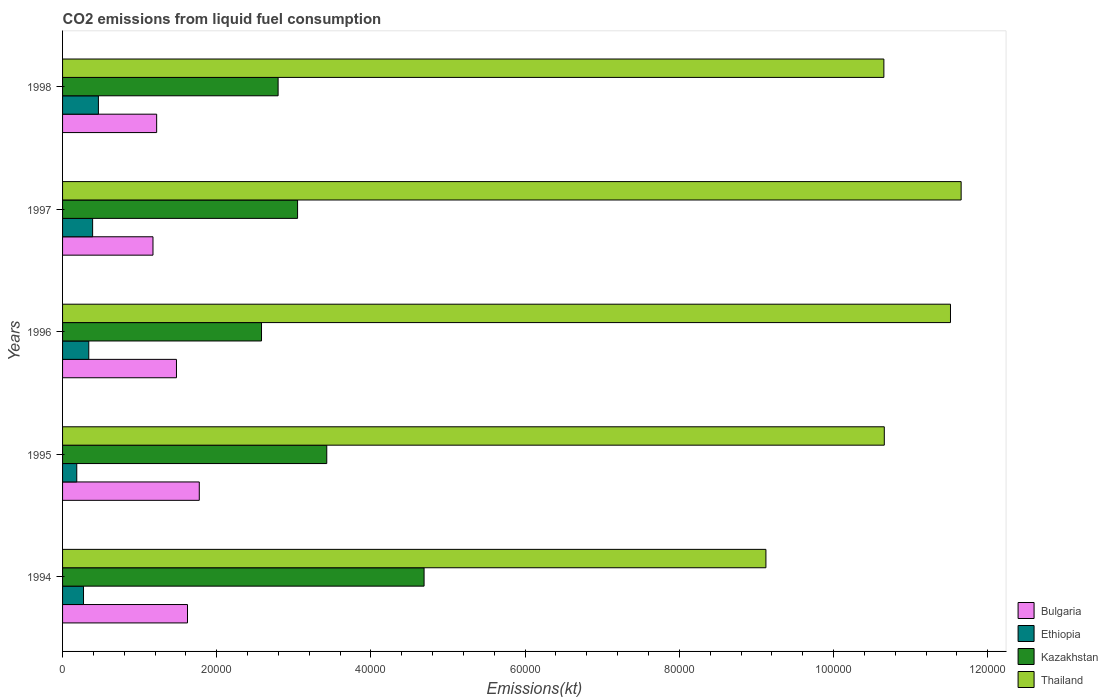How many different coloured bars are there?
Offer a very short reply. 4. How many groups of bars are there?
Your answer should be compact. 5. Are the number of bars on each tick of the Y-axis equal?
Keep it short and to the point. Yes. How many bars are there on the 5th tick from the top?
Provide a short and direct response. 4. What is the label of the 3rd group of bars from the top?
Keep it short and to the point. 1996. What is the amount of CO2 emitted in Kazakhstan in 1995?
Your response must be concise. 3.43e+04. Across all years, what is the maximum amount of CO2 emitted in Bulgaria?
Your response must be concise. 1.77e+04. Across all years, what is the minimum amount of CO2 emitted in Kazakhstan?
Offer a terse response. 2.58e+04. In which year was the amount of CO2 emitted in Thailand maximum?
Provide a succinct answer. 1997. In which year was the amount of CO2 emitted in Bulgaria minimum?
Provide a short and direct response. 1997. What is the total amount of CO2 emitted in Thailand in the graph?
Keep it short and to the point. 5.36e+05. What is the difference between the amount of CO2 emitted in Kazakhstan in 1997 and that in 1998?
Your answer should be compact. 2526.56. What is the difference between the amount of CO2 emitted in Bulgaria in 1996 and the amount of CO2 emitted in Ethiopia in 1995?
Offer a very short reply. 1.29e+04. What is the average amount of CO2 emitted in Thailand per year?
Your response must be concise. 1.07e+05. In the year 1994, what is the difference between the amount of CO2 emitted in Thailand and amount of CO2 emitted in Bulgaria?
Provide a short and direct response. 7.50e+04. In how many years, is the amount of CO2 emitted in Ethiopia greater than 112000 kt?
Your answer should be compact. 0. What is the ratio of the amount of CO2 emitted in Ethiopia in 1994 to that in 1998?
Provide a succinct answer. 0.58. Is the difference between the amount of CO2 emitted in Thailand in 1995 and 1996 greater than the difference between the amount of CO2 emitted in Bulgaria in 1995 and 1996?
Make the answer very short. No. What is the difference between the highest and the second highest amount of CO2 emitted in Bulgaria?
Your answer should be compact. 1529.14. What is the difference between the highest and the lowest amount of CO2 emitted in Kazakhstan?
Give a very brief answer. 2.11e+04. In how many years, is the amount of CO2 emitted in Bulgaria greater than the average amount of CO2 emitted in Bulgaria taken over all years?
Offer a terse response. 3. What does the 2nd bar from the top in 1997 represents?
Offer a very short reply. Kazakhstan. What does the 3rd bar from the bottom in 1997 represents?
Your answer should be compact. Kazakhstan. Are all the bars in the graph horizontal?
Make the answer very short. Yes. How many years are there in the graph?
Offer a very short reply. 5. Are the values on the major ticks of X-axis written in scientific E-notation?
Provide a short and direct response. No. Does the graph contain grids?
Keep it short and to the point. No. What is the title of the graph?
Provide a succinct answer. CO2 emissions from liquid fuel consumption. What is the label or title of the X-axis?
Keep it short and to the point. Emissions(kt). What is the label or title of the Y-axis?
Provide a succinct answer. Years. What is the Emissions(kt) of Bulgaria in 1994?
Your answer should be very brief. 1.62e+04. What is the Emissions(kt) of Ethiopia in 1994?
Offer a very short reply. 2717.25. What is the Emissions(kt) in Kazakhstan in 1994?
Provide a short and direct response. 4.69e+04. What is the Emissions(kt) in Thailand in 1994?
Provide a succinct answer. 9.12e+04. What is the Emissions(kt) of Bulgaria in 1995?
Offer a very short reply. 1.77e+04. What is the Emissions(kt) of Ethiopia in 1995?
Your response must be concise. 1840.83. What is the Emissions(kt) in Kazakhstan in 1995?
Keep it short and to the point. 3.43e+04. What is the Emissions(kt) in Thailand in 1995?
Provide a succinct answer. 1.07e+05. What is the Emissions(kt) in Bulgaria in 1996?
Your answer should be compact. 1.48e+04. What is the Emissions(kt) of Ethiopia in 1996?
Give a very brief answer. 3399.31. What is the Emissions(kt) in Kazakhstan in 1996?
Give a very brief answer. 2.58e+04. What is the Emissions(kt) of Thailand in 1996?
Offer a very short reply. 1.15e+05. What is the Emissions(kt) of Bulgaria in 1997?
Ensure brevity in your answer.  1.17e+04. What is the Emissions(kt) in Ethiopia in 1997?
Your response must be concise. 3898.02. What is the Emissions(kt) in Kazakhstan in 1997?
Ensure brevity in your answer.  3.05e+04. What is the Emissions(kt) of Thailand in 1997?
Your answer should be compact. 1.17e+05. What is the Emissions(kt) in Bulgaria in 1998?
Provide a succinct answer. 1.22e+04. What is the Emissions(kt) of Ethiopia in 1998?
Make the answer very short. 4649.76. What is the Emissions(kt) of Kazakhstan in 1998?
Your answer should be compact. 2.80e+04. What is the Emissions(kt) of Thailand in 1998?
Give a very brief answer. 1.07e+05. Across all years, what is the maximum Emissions(kt) in Bulgaria?
Provide a short and direct response. 1.77e+04. Across all years, what is the maximum Emissions(kt) of Ethiopia?
Give a very brief answer. 4649.76. Across all years, what is the maximum Emissions(kt) of Kazakhstan?
Provide a succinct answer. 4.69e+04. Across all years, what is the maximum Emissions(kt) of Thailand?
Your response must be concise. 1.17e+05. Across all years, what is the minimum Emissions(kt) in Bulgaria?
Your answer should be compact. 1.17e+04. Across all years, what is the minimum Emissions(kt) in Ethiopia?
Offer a very short reply. 1840.83. Across all years, what is the minimum Emissions(kt) of Kazakhstan?
Ensure brevity in your answer.  2.58e+04. Across all years, what is the minimum Emissions(kt) in Thailand?
Your answer should be compact. 9.12e+04. What is the total Emissions(kt) in Bulgaria in the graph?
Your answer should be very brief. 7.26e+04. What is the total Emissions(kt) of Ethiopia in the graph?
Make the answer very short. 1.65e+04. What is the total Emissions(kt) in Kazakhstan in the graph?
Your answer should be compact. 1.65e+05. What is the total Emissions(kt) of Thailand in the graph?
Provide a short and direct response. 5.36e+05. What is the difference between the Emissions(kt) in Bulgaria in 1994 and that in 1995?
Provide a succinct answer. -1529.14. What is the difference between the Emissions(kt) of Ethiopia in 1994 and that in 1995?
Provide a short and direct response. 876.41. What is the difference between the Emissions(kt) in Kazakhstan in 1994 and that in 1995?
Your response must be concise. 1.26e+04. What is the difference between the Emissions(kt) of Thailand in 1994 and that in 1995?
Offer a very short reply. -1.54e+04. What is the difference between the Emissions(kt) in Bulgaria in 1994 and that in 1996?
Ensure brevity in your answer.  1430.13. What is the difference between the Emissions(kt) of Ethiopia in 1994 and that in 1996?
Give a very brief answer. -682.06. What is the difference between the Emissions(kt) in Kazakhstan in 1994 and that in 1996?
Your answer should be very brief. 2.11e+04. What is the difference between the Emissions(kt) in Thailand in 1994 and that in 1996?
Make the answer very short. -2.39e+04. What is the difference between the Emissions(kt) of Bulgaria in 1994 and that in 1997?
Offer a terse response. 4477.41. What is the difference between the Emissions(kt) in Ethiopia in 1994 and that in 1997?
Provide a short and direct response. -1180.77. What is the difference between the Emissions(kt) of Kazakhstan in 1994 and that in 1997?
Provide a succinct answer. 1.64e+04. What is the difference between the Emissions(kt) in Thailand in 1994 and that in 1997?
Provide a succinct answer. -2.53e+04. What is the difference between the Emissions(kt) in Bulgaria in 1994 and that in 1998?
Provide a succinct answer. 4000.7. What is the difference between the Emissions(kt) in Ethiopia in 1994 and that in 1998?
Provide a succinct answer. -1932.51. What is the difference between the Emissions(kt) of Kazakhstan in 1994 and that in 1998?
Offer a terse response. 1.89e+04. What is the difference between the Emissions(kt) of Thailand in 1994 and that in 1998?
Provide a succinct answer. -1.53e+04. What is the difference between the Emissions(kt) of Bulgaria in 1995 and that in 1996?
Your response must be concise. 2959.27. What is the difference between the Emissions(kt) in Ethiopia in 1995 and that in 1996?
Give a very brief answer. -1558.47. What is the difference between the Emissions(kt) in Kazakhstan in 1995 and that in 1996?
Offer a very short reply. 8463.44. What is the difference between the Emissions(kt) of Thailand in 1995 and that in 1996?
Your response must be concise. -8584.45. What is the difference between the Emissions(kt) in Bulgaria in 1995 and that in 1997?
Your answer should be very brief. 6006.55. What is the difference between the Emissions(kt) in Ethiopia in 1995 and that in 1997?
Your response must be concise. -2057.19. What is the difference between the Emissions(kt) in Kazakhstan in 1995 and that in 1997?
Your answer should be compact. 3784.34. What is the difference between the Emissions(kt) in Thailand in 1995 and that in 1997?
Ensure brevity in your answer.  -9966.91. What is the difference between the Emissions(kt) in Bulgaria in 1995 and that in 1998?
Your response must be concise. 5529.84. What is the difference between the Emissions(kt) in Ethiopia in 1995 and that in 1998?
Provide a succinct answer. -2808.92. What is the difference between the Emissions(kt) in Kazakhstan in 1995 and that in 1998?
Make the answer very short. 6310.91. What is the difference between the Emissions(kt) of Thailand in 1995 and that in 1998?
Give a very brief answer. 55.01. What is the difference between the Emissions(kt) in Bulgaria in 1996 and that in 1997?
Give a very brief answer. 3047.28. What is the difference between the Emissions(kt) of Ethiopia in 1996 and that in 1997?
Your answer should be very brief. -498.71. What is the difference between the Emissions(kt) in Kazakhstan in 1996 and that in 1997?
Make the answer very short. -4679.09. What is the difference between the Emissions(kt) of Thailand in 1996 and that in 1997?
Your answer should be compact. -1382.46. What is the difference between the Emissions(kt) in Bulgaria in 1996 and that in 1998?
Your response must be concise. 2570.57. What is the difference between the Emissions(kt) in Ethiopia in 1996 and that in 1998?
Your response must be concise. -1250.45. What is the difference between the Emissions(kt) of Kazakhstan in 1996 and that in 1998?
Your answer should be compact. -2152.53. What is the difference between the Emissions(kt) in Thailand in 1996 and that in 1998?
Offer a terse response. 8639.45. What is the difference between the Emissions(kt) of Bulgaria in 1997 and that in 1998?
Provide a short and direct response. -476.71. What is the difference between the Emissions(kt) of Ethiopia in 1997 and that in 1998?
Offer a terse response. -751.74. What is the difference between the Emissions(kt) in Kazakhstan in 1997 and that in 1998?
Make the answer very short. 2526.56. What is the difference between the Emissions(kt) in Thailand in 1997 and that in 1998?
Provide a succinct answer. 1.00e+04. What is the difference between the Emissions(kt) in Bulgaria in 1994 and the Emissions(kt) in Ethiopia in 1995?
Provide a short and direct response. 1.44e+04. What is the difference between the Emissions(kt) of Bulgaria in 1994 and the Emissions(kt) of Kazakhstan in 1995?
Provide a succinct answer. -1.81e+04. What is the difference between the Emissions(kt) of Bulgaria in 1994 and the Emissions(kt) of Thailand in 1995?
Keep it short and to the point. -9.04e+04. What is the difference between the Emissions(kt) of Ethiopia in 1994 and the Emissions(kt) of Kazakhstan in 1995?
Your answer should be very brief. -3.16e+04. What is the difference between the Emissions(kt) in Ethiopia in 1994 and the Emissions(kt) in Thailand in 1995?
Ensure brevity in your answer.  -1.04e+05. What is the difference between the Emissions(kt) in Kazakhstan in 1994 and the Emissions(kt) in Thailand in 1995?
Keep it short and to the point. -5.97e+04. What is the difference between the Emissions(kt) of Bulgaria in 1994 and the Emissions(kt) of Ethiopia in 1996?
Keep it short and to the point. 1.28e+04. What is the difference between the Emissions(kt) of Bulgaria in 1994 and the Emissions(kt) of Kazakhstan in 1996?
Your answer should be very brief. -9600.21. What is the difference between the Emissions(kt) of Bulgaria in 1994 and the Emissions(kt) of Thailand in 1996?
Keep it short and to the point. -9.90e+04. What is the difference between the Emissions(kt) in Ethiopia in 1994 and the Emissions(kt) in Kazakhstan in 1996?
Your answer should be very brief. -2.31e+04. What is the difference between the Emissions(kt) of Ethiopia in 1994 and the Emissions(kt) of Thailand in 1996?
Offer a very short reply. -1.12e+05. What is the difference between the Emissions(kt) in Kazakhstan in 1994 and the Emissions(kt) in Thailand in 1996?
Offer a very short reply. -6.83e+04. What is the difference between the Emissions(kt) in Bulgaria in 1994 and the Emissions(kt) in Ethiopia in 1997?
Give a very brief answer. 1.23e+04. What is the difference between the Emissions(kt) of Bulgaria in 1994 and the Emissions(kt) of Kazakhstan in 1997?
Keep it short and to the point. -1.43e+04. What is the difference between the Emissions(kt) of Bulgaria in 1994 and the Emissions(kt) of Thailand in 1997?
Your response must be concise. -1.00e+05. What is the difference between the Emissions(kt) in Ethiopia in 1994 and the Emissions(kt) in Kazakhstan in 1997?
Provide a succinct answer. -2.78e+04. What is the difference between the Emissions(kt) of Ethiopia in 1994 and the Emissions(kt) of Thailand in 1997?
Offer a terse response. -1.14e+05. What is the difference between the Emissions(kt) of Kazakhstan in 1994 and the Emissions(kt) of Thailand in 1997?
Keep it short and to the point. -6.97e+04. What is the difference between the Emissions(kt) of Bulgaria in 1994 and the Emissions(kt) of Ethiopia in 1998?
Keep it short and to the point. 1.16e+04. What is the difference between the Emissions(kt) in Bulgaria in 1994 and the Emissions(kt) in Kazakhstan in 1998?
Offer a very short reply. -1.18e+04. What is the difference between the Emissions(kt) of Bulgaria in 1994 and the Emissions(kt) of Thailand in 1998?
Keep it short and to the point. -9.03e+04. What is the difference between the Emissions(kt) of Ethiopia in 1994 and the Emissions(kt) of Kazakhstan in 1998?
Give a very brief answer. -2.52e+04. What is the difference between the Emissions(kt) of Ethiopia in 1994 and the Emissions(kt) of Thailand in 1998?
Provide a short and direct response. -1.04e+05. What is the difference between the Emissions(kt) in Kazakhstan in 1994 and the Emissions(kt) in Thailand in 1998?
Your response must be concise. -5.96e+04. What is the difference between the Emissions(kt) in Bulgaria in 1995 and the Emissions(kt) in Ethiopia in 1996?
Your response must be concise. 1.43e+04. What is the difference between the Emissions(kt) in Bulgaria in 1995 and the Emissions(kt) in Kazakhstan in 1996?
Offer a very short reply. -8071.07. What is the difference between the Emissions(kt) in Bulgaria in 1995 and the Emissions(kt) in Thailand in 1996?
Make the answer very short. -9.74e+04. What is the difference between the Emissions(kt) of Ethiopia in 1995 and the Emissions(kt) of Kazakhstan in 1996?
Provide a short and direct response. -2.40e+04. What is the difference between the Emissions(kt) in Ethiopia in 1995 and the Emissions(kt) in Thailand in 1996?
Provide a short and direct response. -1.13e+05. What is the difference between the Emissions(kt) of Kazakhstan in 1995 and the Emissions(kt) of Thailand in 1996?
Provide a succinct answer. -8.09e+04. What is the difference between the Emissions(kt) in Bulgaria in 1995 and the Emissions(kt) in Ethiopia in 1997?
Your answer should be compact. 1.38e+04. What is the difference between the Emissions(kt) of Bulgaria in 1995 and the Emissions(kt) of Kazakhstan in 1997?
Your answer should be compact. -1.28e+04. What is the difference between the Emissions(kt) of Bulgaria in 1995 and the Emissions(kt) of Thailand in 1997?
Your answer should be very brief. -9.88e+04. What is the difference between the Emissions(kt) of Ethiopia in 1995 and the Emissions(kt) of Kazakhstan in 1997?
Offer a very short reply. -2.86e+04. What is the difference between the Emissions(kt) in Ethiopia in 1995 and the Emissions(kt) in Thailand in 1997?
Your response must be concise. -1.15e+05. What is the difference between the Emissions(kt) of Kazakhstan in 1995 and the Emissions(kt) of Thailand in 1997?
Your answer should be very brief. -8.23e+04. What is the difference between the Emissions(kt) of Bulgaria in 1995 and the Emissions(kt) of Ethiopia in 1998?
Ensure brevity in your answer.  1.31e+04. What is the difference between the Emissions(kt) of Bulgaria in 1995 and the Emissions(kt) of Kazakhstan in 1998?
Give a very brief answer. -1.02e+04. What is the difference between the Emissions(kt) of Bulgaria in 1995 and the Emissions(kt) of Thailand in 1998?
Provide a succinct answer. -8.88e+04. What is the difference between the Emissions(kt) of Ethiopia in 1995 and the Emissions(kt) of Kazakhstan in 1998?
Provide a short and direct response. -2.61e+04. What is the difference between the Emissions(kt) of Ethiopia in 1995 and the Emissions(kt) of Thailand in 1998?
Provide a short and direct response. -1.05e+05. What is the difference between the Emissions(kt) of Kazakhstan in 1995 and the Emissions(kt) of Thailand in 1998?
Your response must be concise. -7.23e+04. What is the difference between the Emissions(kt) in Bulgaria in 1996 and the Emissions(kt) in Ethiopia in 1997?
Make the answer very short. 1.09e+04. What is the difference between the Emissions(kt) of Bulgaria in 1996 and the Emissions(kt) of Kazakhstan in 1997?
Ensure brevity in your answer.  -1.57e+04. What is the difference between the Emissions(kt) of Bulgaria in 1996 and the Emissions(kt) of Thailand in 1997?
Provide a succinct answer. -1.02e+05. What is the difference between the Emissions(kt) of Ethiopia in 1996 and the Emissions(kt) of Kazakhstan in 1997?
Offer a very short reply. -2.71e+04. What is the difference between the Emissions(kt) of Ethiopia in 1996 and the Emissions(kt) of Thailand in 1997?
Your response must be concise. -1.13e+05. What is the difference between the Emissions(kt) of Kazakhstan in 1996 and the Emissions(kt) of Thailand in 1997?
Provide a short and direct response. -9.07e+04. What is the difference between the Emissions(kt) in Bulgaria in 1996 and the Emissions(kt) in Ethiopia in 1998?
Offer a terse response. 1.01e+04. What is the difference between the Emissions(kt) of Bulgaria in 1996 and the Emissions(kt) of Kazakhstan in 1998?
Offer a very short reply. -1.32e+04. What is the difference between the Emissions(kt) of Bulgaria in 1996 and the Emissions(kt) of Thailand in 1998?
Make the answer very short. -9.18e+04. What is the difference between the Emissions(kt) of Ethiopia in 1996 and the Emissions(kt) of Kazakhstan in 1998?
Provide a short and direct response. -2.46e+04. What is the difference between the Emissions(kt) of Ethiopia in 1996 and the Emissions(kt) of Thailand in 1998?
Offer a terse response. -1.03e+05. What is the difference between the Emissions(kt) in Kazakhstan in 1996 and the Emissions(kt) in Thailand in 1998?
Offer a very short reply. -8.07e+04. What is the difference between the Emissions(kt) of Bulgaria in 1997 and the Emissions(kt) of Ethiopia in 1998?
Offer a very short reply. 7077.31. What is the difference between the Emissions(kt) in Bulgaria in 1997 and the Emissions(kt) in Kazakhstan in 1998?
Keep it short and to the point. -1.62e+04. What is the difference between the Emissions(kt) in Bulgaria in 1997 and the Emissions(kt) in Thailand in 1998?
Make the answer very short. -9.48e+04. What is the difference between the Emissions(kt) of Ethiopia in 1997 and the Emissions(kt) of Kazakhstan in 1998?
Keep it short and to the point. -2.41e+04. What is the difference between the Emissions(kt) of Ethiopia in 1997 and the Emissions(kt) of Thailand in 1998?
Offer a very short reply. -1.03e+05. What is the difference between the Emissions(kt) in Kazakhstan in 1997 and the Emissions(kt) in Thailand in 1998?
Your answer should be compact. -7.60e+04. What is the average Emissions(kt) of Bulgaria per year?
Make the answer very short. 1.45e+04. What is the average Emissions(kt) in Ethiopia per year?
Give a very brief answer. 3301.03. What is the average Emissions(kt) of Kazakhstan per year?
Offer a terse response. 3.31e+04. What is the average Emissions(kt) of Thailand per year?
Offer a terse response. 1.07e+05. In the year 1994, what is the difference between the Emissions(kt) of Bulgaria and Emissions(kt) of Ethiopia?
Provide a succinct answer. 1.35e+04. In the year 1994, what is the difference between the Emissions(kt) in Bulgaria and Emissions(kt) in Kazakhstan?
Offer a terse response. -3.07e+04. In the year 1994, what is the difference between the Emissions(kt) in Bulgaria and Emissions(kt) in Thailand?
Give a very brief answer. -7.50e+04. In the year 1994, what is the difference between the Emissions(kt) of Ethiopia and Emissions(kt) of Kazakhstan?
Offer a very short reply. -4.42e+04. In the year 1994, what is the difference between the Emissions(kt) in Ethiopia and Emissions(kt) in Thailand?
Offer a terse response. -8.85e+04. In the year 1994, what is the difference between the Emissions(kt) of Kazakhstan and Emissions(kt) of Thailand?
Give a very brief answer. -4.43e+04. In the year 1995, what is the difference between the Emissions(kt) of Bulgaria and Emissions(kt) of Ethiopia?
Ensure brevity in your answer.  1.59e+04. In the year 1995, what is the difference between the Emissions(kt) in Bulgaria and Emissions(kt) in Kazakhstan?
Your answer should be very brief. -1.65e+04. In the year 1995, what is the difference between the Emissions(kt) in Bulgaria and Emissions(kt) in Thailand?
Offer a very short reply. -8.89e+04. In the year 1995, what is the difference between the Emissions(kt) in Ethiopia and Emissions(kt) in Kazakhstan?
Make the answer very short. -3.24e+04. In the year 1995, what is the difference between the Emissions(kt) in Ethiopia and Emissions(kt) in Thailand?
Your answer should be compact. -1.05e+05. In the year 1995, what is the difference between the Emissions(kt) of Kazakhstan and Emissions(kt) of Thailand?
Your answer should be compact. -7.23e+04. In the year 1996, what is the difference between the Emissions(kt) of Bulgaria and Emissions(kt) of Ethiopia?
Keep it short and to the point. 1.14e+04. In the year 1996, what is the difference between the Emissions(kt) in Bulgaria and Emissions(kt) in Kazakhstan?
Your answer should be very brief. -1.10e+04. In the year 1996, what is the difference between the Emissions(kt) of Bulgaria and Emissions(kt) of Thailand?
Keep it short and to the point. -1.00e+05. In the year 1996, what is the difference between the Emissions(kt) of Ethiopia and Emissions(kt) of Kazakhstan?
Provide a short and direct response. -2.24e+04. In the year 1996, what is the difference between the Emissions(kt) of Ethiopia and Emissions(kt) of Thailand?
Ensure brevity in your answer.  -1.12e+05. In the year 1996, what is the difference between the Emissions(kt) of Kazakhstan and Emissions(kt) of Thailand?
Offer a very short reply. -8.94e+04. In the year 1997, what is the difference between the Emissions(kt) in Bulgaria and Emissions(kt) in Ethiopia?
Keep it short and to the point. 7829.05. In the year 1997, what is the difference between the Emissions(kt) in Bulgaria and Emissions(kt) in Kazakhstan?
Your answer should be very brief. -1.88e+04. In the year 1997, what is the difference between the Emissions(kt) of Bulgaria and Emissions(kt) of Thailand?
Ensure brevity in your answer.  -1.05e+05. In the year 1997, what is the difference between the Emissions(kt) of Ethiopia and Emissions(kt) of Kazakhstan?
Keep it short and to the point. -2.66e+04. In the year 1997, what is the difference between the Emissions(kt) in Ethiopia and Emissions(kt) in Thailand?
Make the answer very short. -1.13e+05. In the year 1997, what is the difference between the Emissions(kt) of Kazakhstan and Emissions(kt) of Thailand?
Your answer should be compact. -8.61e+04. In the year 1998, what is the difference between the Emissions(kt) of Bulgaria and Emissions(kt) of Ethiopia?
Keep it short and to the point. 7554.02. In the year 1998, what is the difference between the Emissions(kt) in Bulgaria and Emissions(kt) in Kazakhstan?
Offer a very short reply. -1.58e+04. In the year 1998, what is the difference between the Emissions(kt) of Bulgaria and Emissions(kt) of Thailand?
Provide a succinct answer. -9.43e+04. In the year 1998, what is the difference between the Emissions(kt) in Ethiopia and Emissions(kt) in Kazakhstan?
Offer a terse response. -2.33e+04. In the year 1998, what is the difference between the Emissions(kt) in Ethiopia and Emissions(kt) in Thailand?
Offer a terse response. -1.02e+05. In the year 1998, what is the difference between the Emissions(kt) in Kazakhstan and Emissions(kt) in Thailand?
Provide a succinct answer. -7.86e+04. What is the ratio of the Emissions(kt) of Bulgaria in 1994 to that in 1995?
Offer a terse response. 0.91. What is the ratio of the Emissions(kt) of Ethiopia in 1994 to that in 1995?
Provide a succinct answer. 1.48. What is the ratio of the Emissions(kt) of Kazakhstan in 1994 to that in 1995?
Provide a short and direct response. 1.37. What is the ratio of the Emissions(kt) in Thailand in 1994 to that in 1995?
Ensure brevity in your answer.  0.86. What is the ratio of the Emissions(kt) in Bulgaria in 1994 to that in 1996?
Keep it short and to the point. 1.1. What is the ratio of the Emissions(kt) of Ethiopia in 1994 to that in 1996?
Ensure brevity in your answer.  0.8. What is the ratio of the Emissions(kt) in Kazakhstan in 1994 to that in 1996?
Provide a succinct answer. 1.82. What is the ratio of the Emissions(kt) in Thailand in 1994 to that in 1996?
Give a very brief answer. 0.79. What is the ratio of the Emissions(kt) of Bulgaria in 1994 to that in 1997?
Your response must be concise. 1.38. What is the ratio of the Emissions(kt) of Ethiopia in 1994 to that in 1997?
Keep it short and to the point. 0.7. What is the ratio of the Emissions(kt) of Kazakhstan in 1994 to that in 1997?
Your response must be concise. 1.54. What is the ratio of the Emissions(kt) of Thailand in 1994 to that in 1997?
Keep it short and to the point. 0.78. What is the ratio of the Emissions(kt) of Bulgaria in 1994 to that in 1998?
Offer a terse response. 1.33. What is the ratio of the Emissions(kt) in Ethiopia in 1994 to that in 1998?
Provide a succinct answer. 0.58. What is the ratio of the Emissions(kt) of Kazakhstan in 1994 to that in 1998?
Your answer should be compact. 1.68. What is the ratio of the Emissions(kt) in Thailand in 1994 to that in 1998?
Offer a very short reply. 0.86. What is the ratio of the Emissions(kt) in Bulgaria in 1995 to that in 1996?
Your answer should be very brief. 1.2. What is the ratio of the Emissions(kt) of Ethiopia in 1995 to that in 1996?
Offer a terse response. 0.54. What is the ratio of the Emissions(kt) in Kazakhstan in 1995 to that in 1996?
Provide a succinct answer. 1.33. What is the ratio of the Emissions(kt) of Thailand in 1995 to that in 1996?
Your answer should be compact. 0.93. What is the ratio of the Emissions(kt) of Bulgaria in 1995 to that in 1997?
Your answer should be very brief. 1.51. What is the ratio of the Emissions(kt) in Ethiopia in 1995 to that in 1997?
Offer a very short reply. 0.47. What is the ratio of the Emissions(kt) in Kazakhstan in 1995 to that in 1997?
Your answer should be compact. 1.12. What is the ratio of the Emissions(kt) of Thailand in 1995 to that in 1997?
Offer a very short reply. 0.91. What is the ratio of the Emissions(kt) in Bulgaria in 1995 to that in 1998?
Give a very brief answer. 1.45. What is the ratio of the Emissions(kt) in Ethiopia in 1995 to that in 1998?
Your answer should be compact. 0.4. What is the ratio of the Emissions(kt) in Kazakhstan in 1995 to that in 1998?
Provide a short and direct response. 1.23. What is the ratio of the Emissions(kt) of Thailand in 1995 to that in 1998?
Your answer should be very brief. 1. What is the ratio of the Emissions(kt) in Bulgaria in 1996 to that in 1997?
Provide a succinct answer. 1.26. What is the ratio of the Emissions(kt) in Ethiopia in 1996 to that in 1997?
Provide a succinct answer. 0.87. What is the ratio of the Emissions(kt) in Kazakhstan in 1996 to that in 1997?
Provide a succinct answer. 0.85. What is the ratio of the Emissions(kt) of Bulgaria in 1996 to that in 1998?
Offer a very short reply. 1.21. What is the ratio of the Emissions(kt) in Ethiopia in 1996 to that in 1998?
Give a very brief answer. 0.73. What is the ratio of the Emissions(kt) of Kazakhstan in 1996 to that in 1998?
Your response must be concise. 0.92. What is the ratio of the Emissions(kt) in Thailand in 1996 to that in 1998?
Offer a terse response. 1.08. What is the ratio of the Emissions(kt) in Bulgaria in 1997 to that in 1998?
Give a very brief answer. 0.96. What is the ratio of the Emissions(kt) of Ethiopia in 1997 to that in 1998?
Your answer should be very brief. 0.84. What is the ratio of the Emissions(kt) of Kazakhstan in 1997 to that in 1998?
Keep it short and to the point. 1.09. What is the ratio of the Emissions(kt) of Thailand in 1997 to that in 1998?
Your answer should be very brief. 1.09. What is the difference between the highest and the second highest Emissions(kt) in Bulgaria?
Ensure brevity in your answer.  1529.14. What is the difference between the highest and the second highest Emissions(kt) in Ethiopia?
Offer a very short reply. 751.74. What is the difference between the highest and the second highest Emissions(kt) in Kazakhstan?
Offer a terse response. 1.26e+04. What is the difference between the highest and the second highest Emissions(kt) of Thailand?
Your answer should be very brief. 1382.46. What is the difference between the highest and the lowest Emissions(kt) in Bulgaria?
Ensure brevity in your answer.  6006.55. What is the difference between the highest and the lowest Emissions(kt) in Ethiopia?
Make the answer very short. 2808.92. What is the difference between the highest and the lowest Emissions(kt) of Kazakhstan?
Offer a terse response. 2.11e+04. What is the difference between the highest and the lowest Emissions(kt) of Thailand?
Provide a short and direct response. 2.53e+04. 